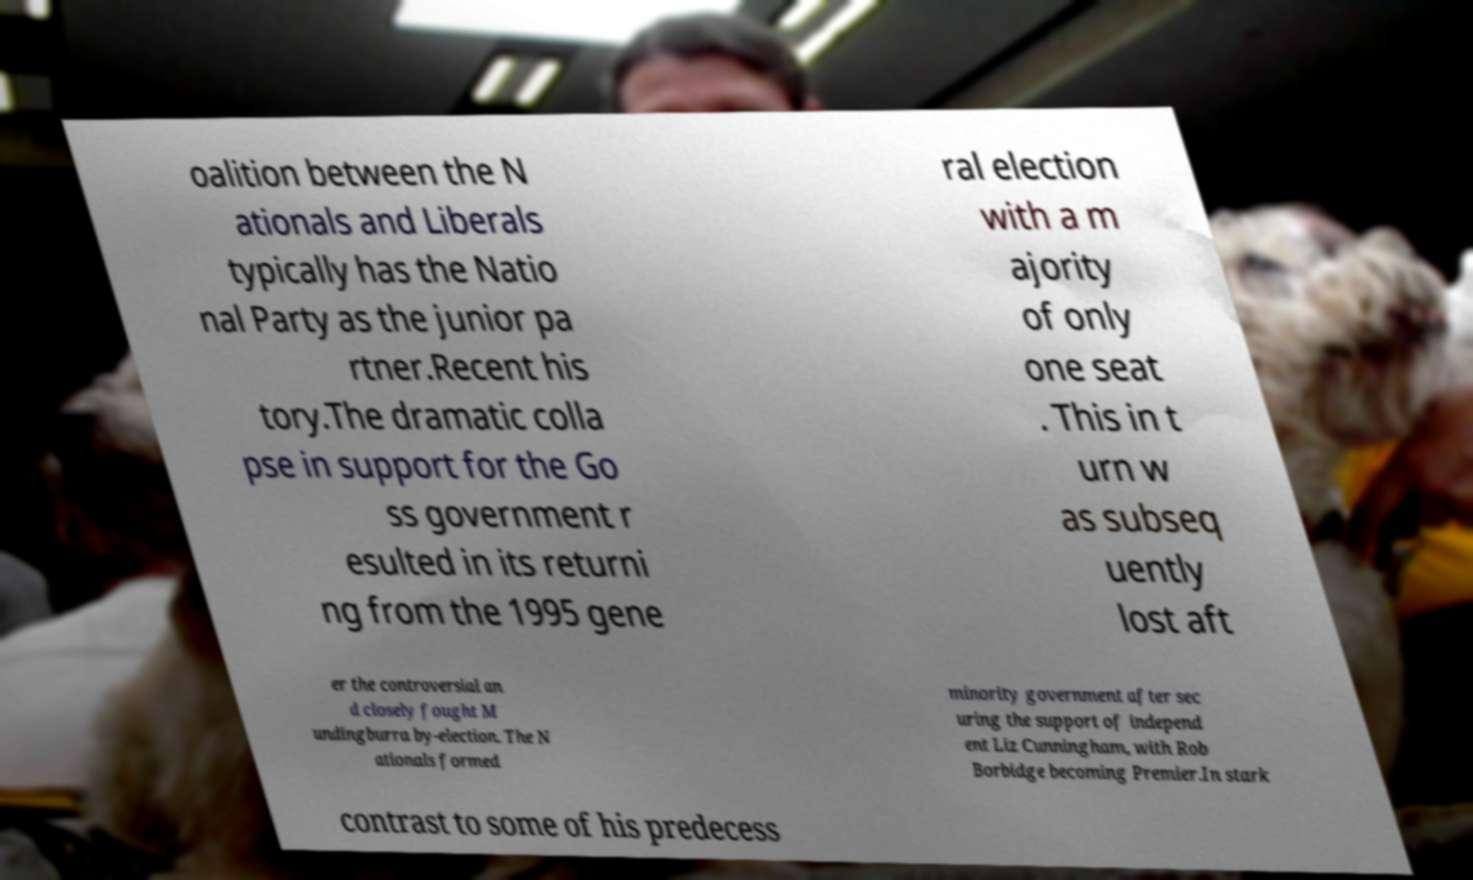Could you assist in decoding the text presented in this image and type it out clearly? oalition between the N ationals and Liberals typically has the Natio nal Party as the junior pa rtner.Recent his tory.The dramatic colla pse in support for the Go ss government r esulted in its returni ng from the 1995 gene ral election with a m ajority of only one seat . This in t urn w as subseq uently lost aft er the controversial an d closely fought M undingburra by-election. The N ationals formed minority government after sec uring the support of independ ent Liz Cunningham, with Rob Borbidge becoming Premier.In stark contrast to some of his predecess 